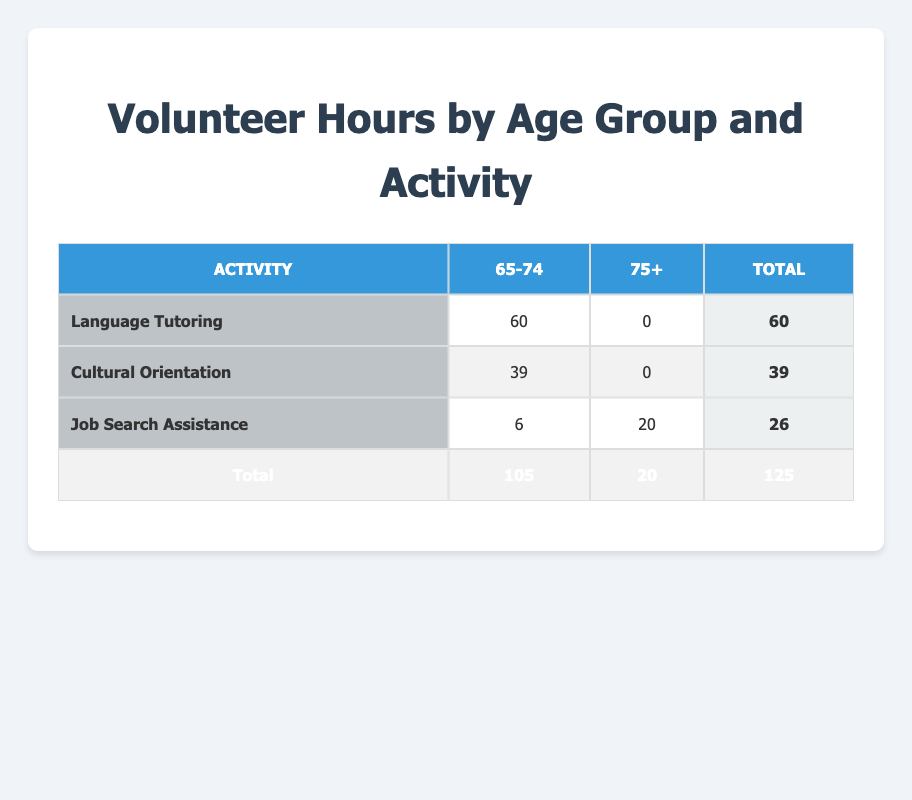What is the total number of volunteer hours contributed by the 65-74 age group? To find the total for the 65-74 age group, we add the hours from each activity: Language Tutoring (60) + Cultural Orientation (39) + Job Search Assistance (6) = 105 hours.
Answer: 105 How many total hours were contributed to Cultural Orientation? There are 39 total hours contributed to Cultural Orientation in the 65-74 age group, and 0 in the 75+ age group. Therefore, the total remains 39.
Answer: 39 Did any volunteers aged 75+ contribute to Language Tutoring? Checking the table, the 75+ age group has 0 hours under Language Tutoring. This indicates that no volunteers aged 75+ participated in that activity.
Answer: No What is the difference in total hours contributed between the two age groups? For the 65-74 age group, the total is 105 hours, and for the 75+ age group, the total is 20 hours. The difference is 105 - 20 = 85 hours.
Answer: 85 How many total hours of Job Search Assistance were contributed? The total for Job Search Assistance is the sum of hours from both age groups: 6 hours from the 65-74 age group and 20 hours from the 75+ age group, which sums to 26 hours.
Answer: 26 Which activity received the highest total hours of contribution? By comparing the totals: Language Tutoring (60), Cultural Orientation (39), and Job Search Assistance (26), Language Tutoring has the highest total at 60 hours.
Answer: Language Tutoring What percentage of the total volunteer hours came from the 75+ age group? To find the percentage, divide the total hours from the 75+ age group (20) by the grand total (125) and multiply by 100. So, (20/125) * 100 = 16%.
Answer: 16% Which age group contributed more hours to Job Search Assistance? The 65-74 age group contributed 6 hours, while the 75+ age group contributed 20 hours, making the 75+ age group more active in Job Search Assistance by 14 hours.
Answer: 75+ age group Calculate the average hours contributed by the 65-74 age group across all activities. The total hours contributed by the 65-74 age group is 105 hours, and there are 3 activities. Therefore, the average is 105 / 3 = 35 hours.
Answer: 35 